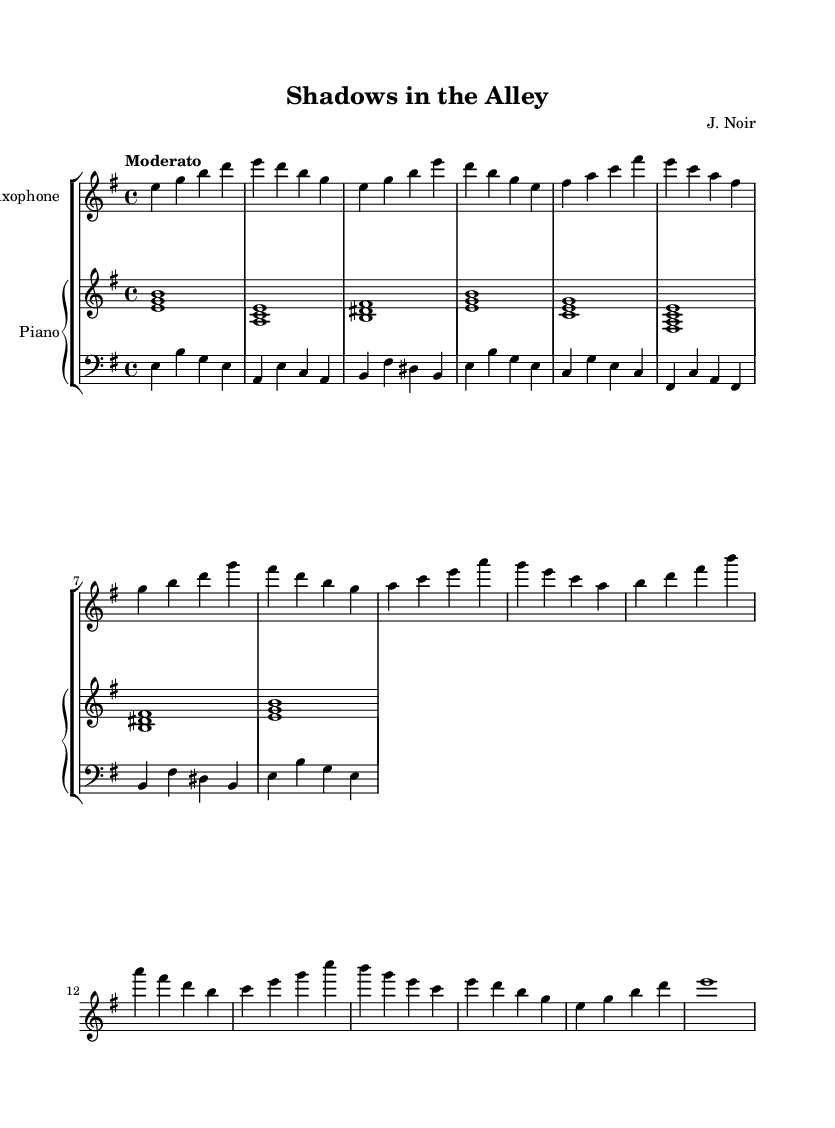What is the key signature of this music? The key signature is represented by the absence of sharps or flats that are notated at the beginning of the staff. The music is in E minor, which has one sharp (F#), but it is often visually depicted without the accidentals in this context.
Answer: E minor What is the time signature of this music? The time signature appears at the beginning of the piece, indicated by the fraction. Here, it shows four beats per measure with a quarter note getting the beat. Thus, the measure consists of four quarter notes.
Answer: 4/4 What is the tempo marking of this piece? The tempo marking is a directive indicating the speed at which the piece should be played. In this instance, it states "Moderato," which is a standard tempo indication implying a moderate speed.
Answer: Moderato How many measures are present in the score? To determine the number of measures, you count the distinct groups of notes or rests separated by vertical bar lines on the staff. In this case, the score contains a total of 12 measures for the saxophone part.
Answer: 12 Which instrument plays the bass line? The bass line is typically written in the bass clef, which is clearly noted at the beginning of the corresponding staff. In this score, the instrument labeled in the bass clef is the bass.
Answer: Bass What is the last note value in the saxophone part? To find the last note value, look at the final measure of the saxophone part. It consists of a whole note, which occupies an entire measure by itself.
Answer: Whole note How does the harmony support the theme of film noir? While the music itself does not explicitly tell a story, the use of minor chords and jazz harmonies creates a somber and mysterious atmosphere, very characteristic of film noir. These elements draw upon tension and introspection that aligns with the genre’s themes.
Answer: Jazz harmonies 